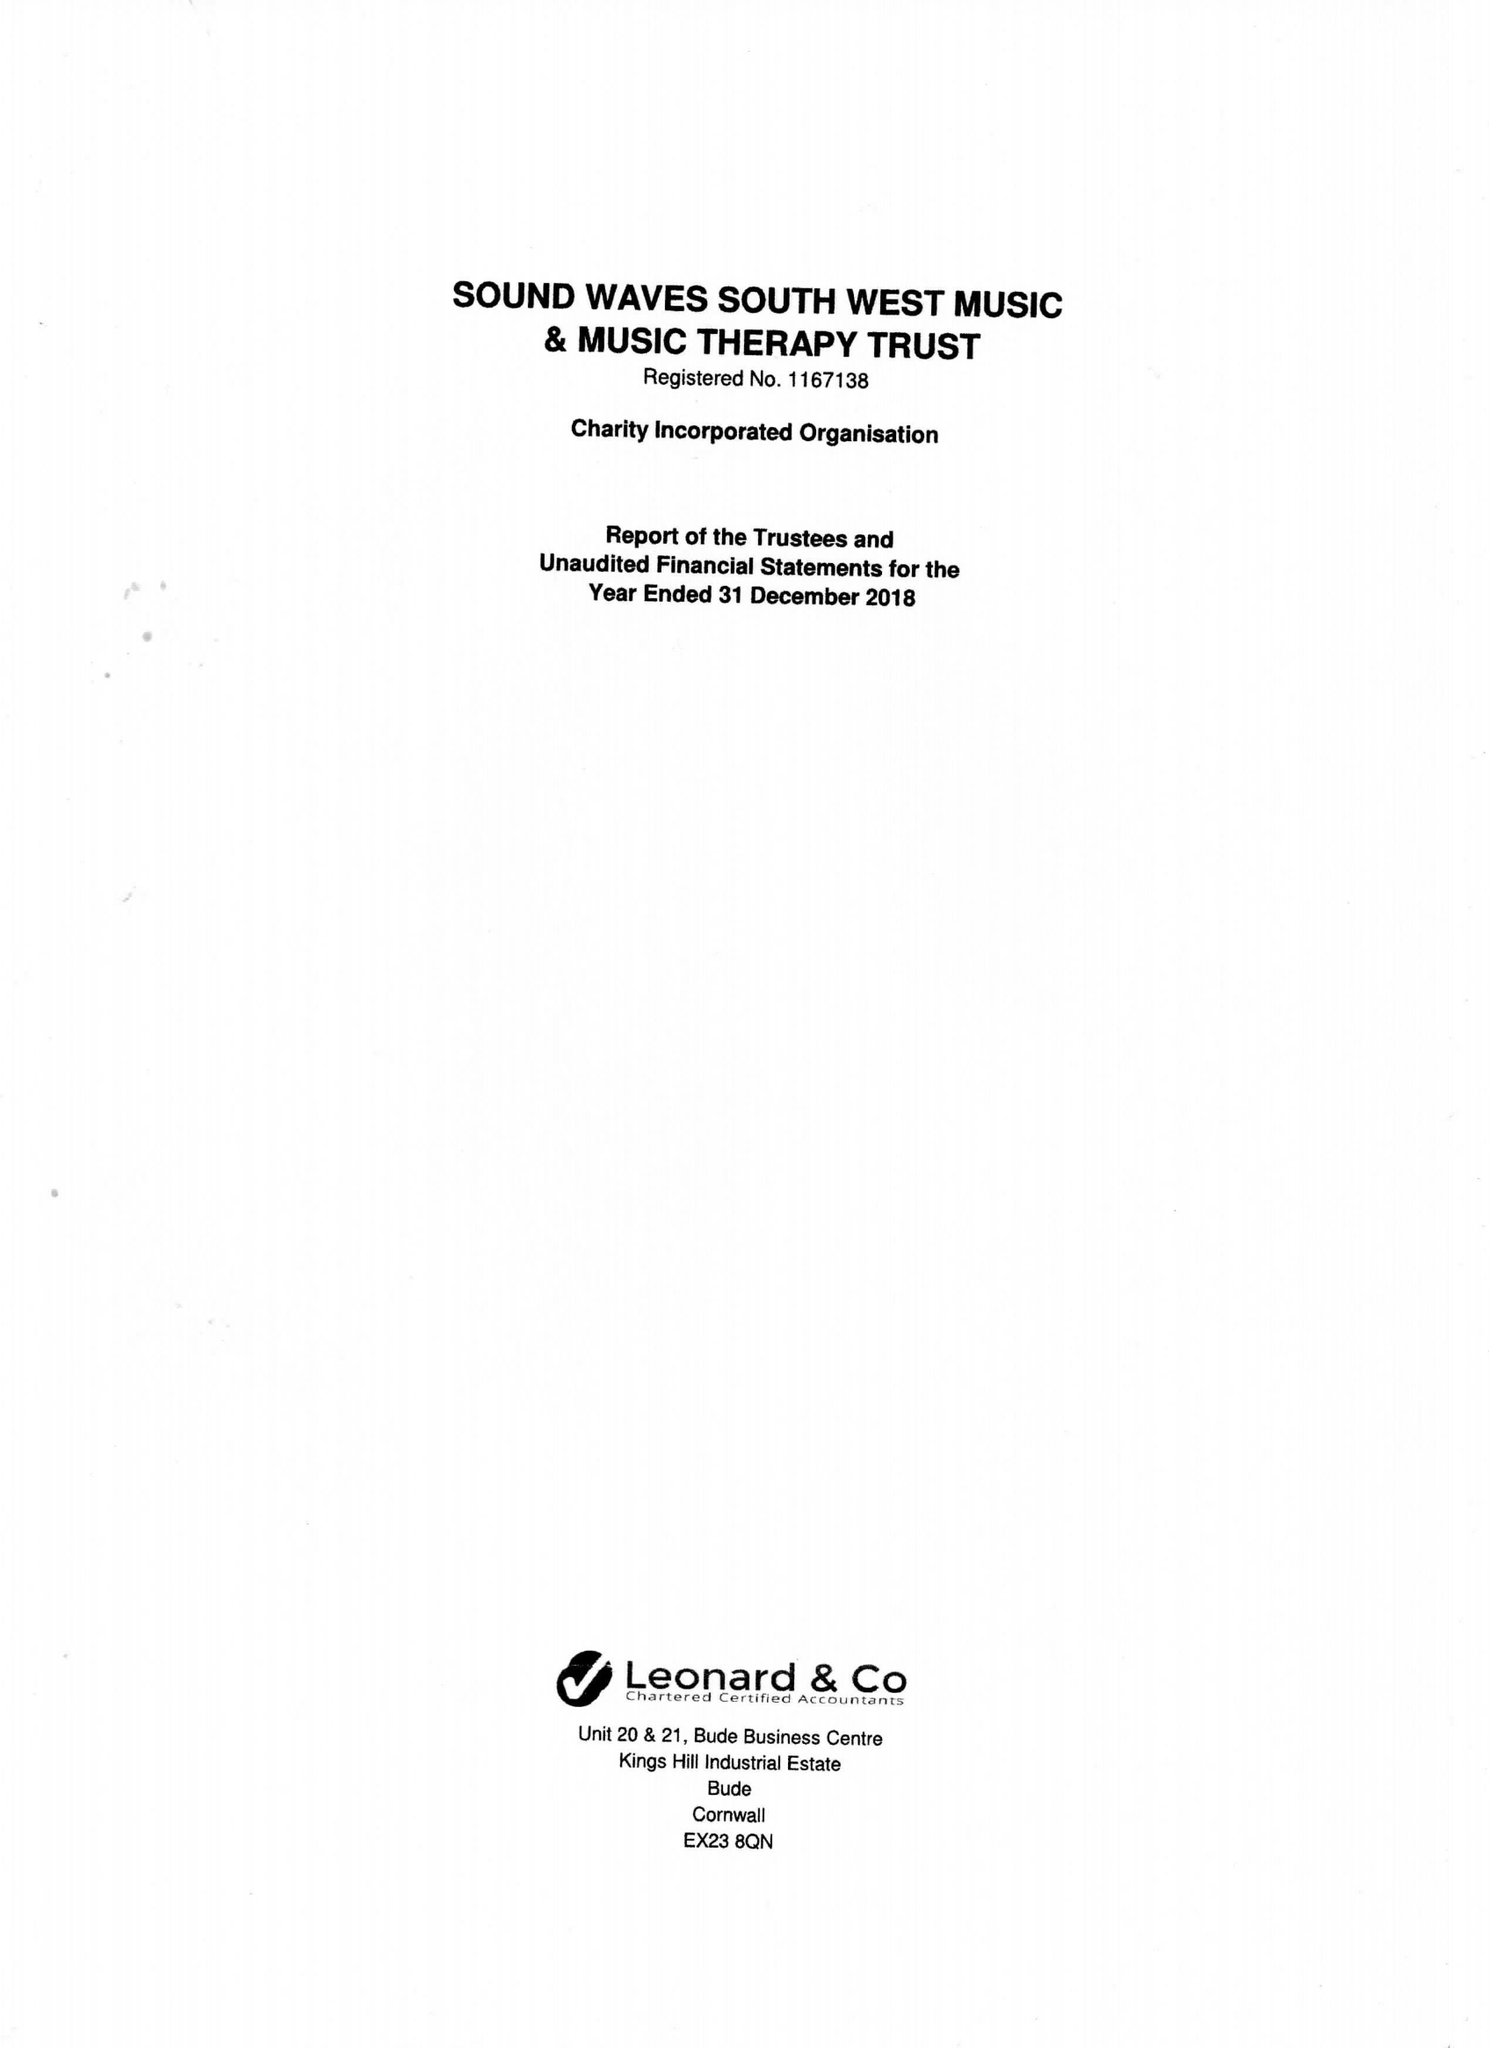What is the value for the spending_annually_in_british_pounds?
Answer the question using a single word or phrase. 34942.00 